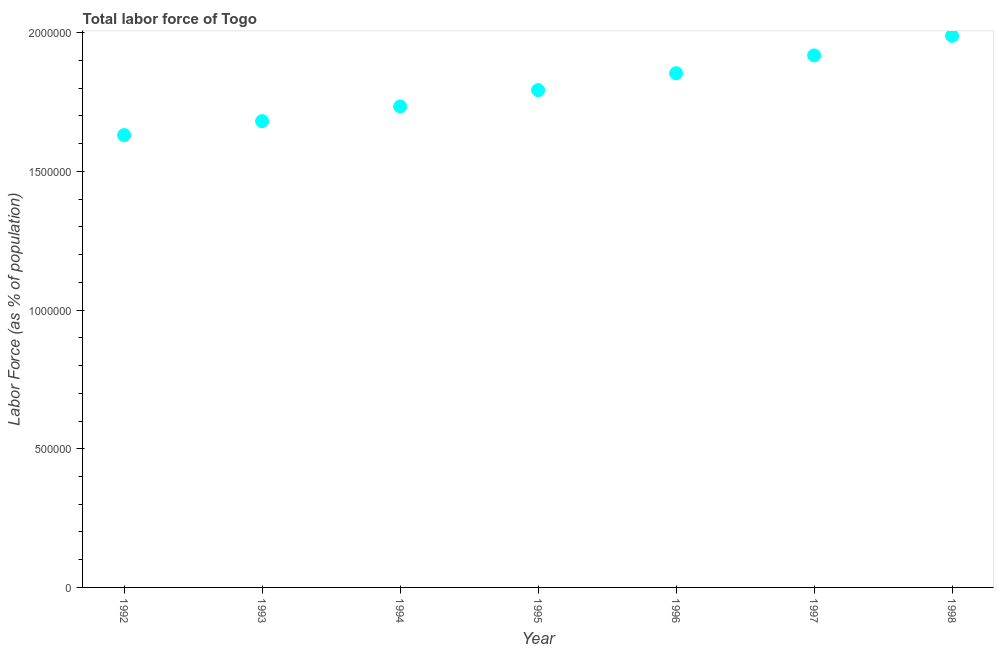What is the total labor force in 1996?
Keep it short and to the point. 1.85e+06. Across all years, what is the maximum total labor force?
Your answer should be compact. 1.99e+06. Across all years, what is the minimum total labor force?
Your answer should be compact. 1.63e+06. In which year was the total labor force minimum?
Provide a succinct answer. 1992. What is the sum of the total labor force?
Your response must be concise. 1.26e+07. What is the difference between the total labor force in 1992 and 1993?
Ensure brevity in your answer.  -5.02e+04. What is the average total labor force per year?
Offer a terse response. 1.80e+06. What is the median total labor force?
Offer a terse response. 1.79e+06. What is the ratio of the total labor force in 1993 to that in 1998?
Make the answer very short. 0.85. Is the total labor force in 1992 less than that in 1998?
Provide a succinct answer. Yes. What is the difference between the highest and the second highest total labor force?
Make the answer very short. 7.06e+04. Is the sum of the total labor force in 1994 and 1998 greater than the maximum total labor force across all years?
Keep it short and to the point. Yes. What is the difference between the highest and the lowest total labor force?
Keep it short and to the point. 3.58e+05. In how many years, is the total labor force greater than the average total labor force taken over all years?
Offer a very short reply. 3. How many years are there in the graph?
Provide a short and direct response. 7. What is the title of the graph?
Your answer should be very brief. Total labor force of Togo. What is the label or title of the X-axis?
Make the answer very short. Year. What is the label or title of the Y-axis?
Your answer should be very brief. Labor Force (as % of population). What is the Labor Force (as % of population) in 1992?
Ensure brevity in your answer.  1.63e+06. What is the Labor Force (as % of population) in 1993?
Offer a very short reply. 1.68e+06. What is the Labor Force (as % of population) in 1994?
Provide a short and direct response. 1.73e+06. What is the Labor Force (as % of population) in 1995?
Your answer should be compact. 1.79e+06. What is the Labor Force (as % of population) in 1996?
Give a very brief answer. 1.85e+06. What is the Labor Force (as % of population) in 1997?
Give a very brief answer. 1.92e+06. What is the Labor Force (as % of population) in 1998?
Keep it short and to the point. 1.99e+06. What is the difference between the Labor Force (as % of population) in 1992 and 1993?
Give a very brief answer. -5.02e+04. What is the difference between the Labor Force (as % of population) in 1992 and 1994?
Provide a short and direct response. -1.03e+05. What is the difference between the Labor Force (as % of population) in 1992 and 1995?
Your answer should be compact. -1.62e+05. What is the difference between the Labor Force (as % of population) in 1992 and 1996?
Provide a short and direct response. -2.23e+05. What is the difference between the Labor Force (as % of population) in 1992 and 1997?
Make the answer very short. -2.87e+05. What is the difference between the Labor Force (as % of population) in 1992 and 1998?
Offer a very short reply. -3.58e+05. What is the difference between the Labor Force (as % of population) in 1993 and 1994?
Ensure brevity in your answer.  -5.31e+04. What is the difference between the Labor Force (as % of population) in 1993 and 1995?
Your answer should be compact. -1.12e+05. What is the difference between the Labor Force (as % of population) in 1993 and 1996?
Keep it short and to the point. -1.73e+05. What is the difference between the Labor Force (as % of population) in 1993 and 1997?
Ensure brevity in your answer.  -2.37e+05. What is the difference between the Labor Force (as % of population) in 1993 and 1998?
Your response must be concise. -3.08e+05. What is the difference between the Labor Force (as % of population) in 1994 and 1995?
Provide a short and direct response. -5.88e+04. What is the difference between the Labor Force (as % of population) in 1994 and 1996?
Give a very brief answer. -1.20e+05. What is the difference between the Labor Force (as % of population) in 1994 and 1997?
Provide a succinct answer. -1.84e+05. What is the difference between the Labor Force (as % of population) in 1994 and 1998?
Provide a short and direct response. -2.55e+05. What is the difference between the Labor Force (as % of population) in 1995 and 1996?
Provide a succinct answer. -6.08e+04. What is the difference between the Labor Force (as % of population) in 1995 and 1997?
Your answer should be very brief. -1.25e+05. What is the difference between the Labor Force (as % of population) in 1995 and 1998?
Your answer should be very brief. -1.96e+05. What is the difference between the Labor Force (as % of population) in 1996 and 1997?
Make the answer very short. -6.45e+04. What is the difference between the Labor Force (as % of population) in 1996 and 1998?
Your answer should be compact. -1.35e+05. What is the difference between the Labor Force (as % of population) in 1997 and 1998?
Ensure brevity in your answer.  -7.06e+04. What is the ratio of the Labor Force (as % of population) in 1992 to that in 1993?
Provide a succinct answer. 0.97. What is the ratio of the Labor Force (as % of population) in 1992 to that in 1994?
Your answer should be compact. 0.94. What is the ratio of the Labor Force (as % of population) in 1992 to that in 1995?
Provide a succinct answer. 0.91. What is the ratio of the Labor Force (as % of population) in 1992 to that in 1998?
Your answer should be compact. 0.82. What is the ratio of the Labor Force (as % of population) in 1993 to that in 1994?
Offer a terse response. 0.97. What is the ratio of the Labor Force (as % of population) in 1993 to that in 1995?
Ensure brevity in your answer.  0.94. What is the ratio of the Labor Force (as % of population) in 1993 to that in 1996?
Keep it short and to the point. 0.91. What is the ratio of the Labor Force (as % of population) in 1993 to that in 1997?
Your response must be concise. 0.88. What is the ratio of the Labor Force (as % of population) in 1993 to that in 1998?
Ensure brevity in your answer.  0.84. What is the ratio of the Labor Force (as % of population) in 1994 to that in 1996?
Ensure brevity in your answer.  0.94. What is the ratio of the Labor Force (as % of population) in 1994 to that in 1997?
Your response must be concise. 0.9. What is the ratio of the Labor Force (as % of population) in 1994 to that in 1998?
Make the answer very short. 0.87. What is the ratio of the Labor Force (as % of population) in 1995 to that in 1996?
Your response must be concise. 0.97. What is the ratio of the Labor Force (as % of population) in 1995 to that in 1997?
Keep it short and to the point. 0.94. What is the ratio of the Labor Force (as % of population) in 1995 to that in 1998?
Ensure brevity in your answer.  0.9. What is the ratio of the Labor Force (as % of population) in 1996 to that in 1998?
Give a very brief answer. 0.93. 